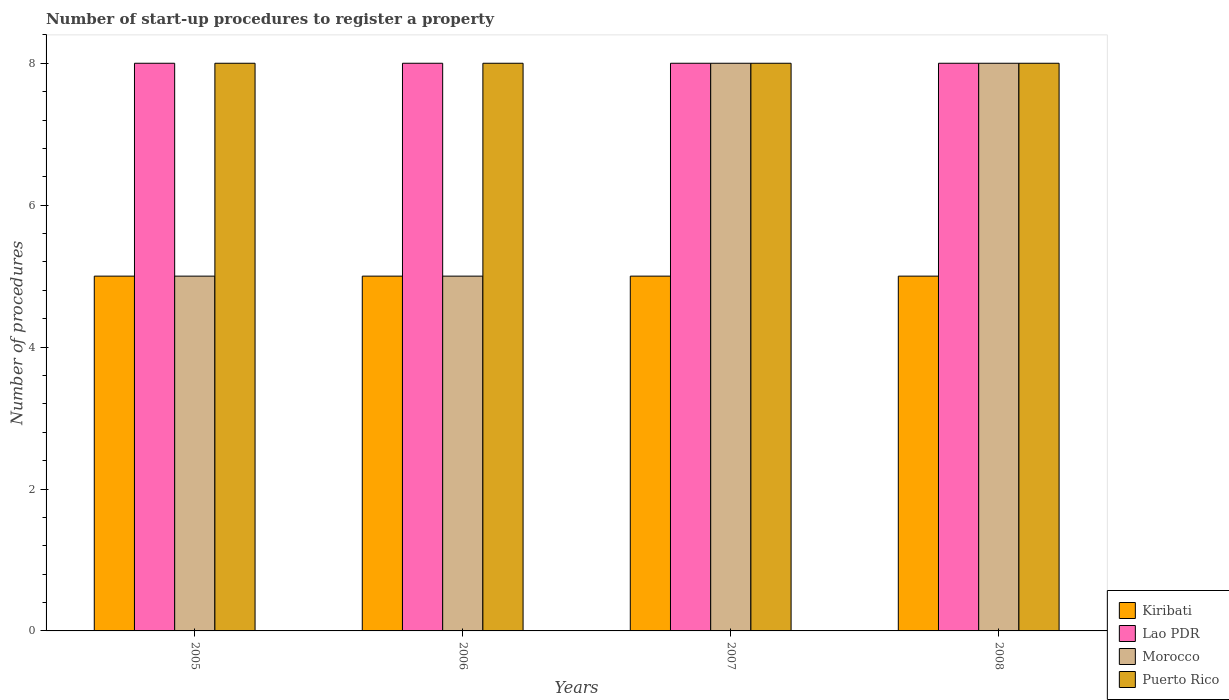Are the number of bars on each tick of the X-axis equal?
Provide a short and direct response. Yes. How many bars are there on the 4th tick from the left?
Keep it short and to the point. 4. How many bars are there on the 2nd tick from the right?
Your answer should be compact. 4. In how many cases, is the number of bars for a given year not equal to the number of legend labels?
Offer a terse response. 0. What is the number of procedures required to register a property in Puerto Rico in 2005?
Ensure brevity in your answer.  8. Across all years, what is the maximum number of procedures required to register a property in Lao PDR?
Ensure brevity in your answer.  8. Across all years, what is the minimum number of procedures required to register a property in Puerto Rico?
Keep it short and to the point. 8. In which year was the number of procedures required to register a property in Lao PDR minimum?
Give a very brief answer. 2005. What is the total number of procedures required to register a property in Kiribati in the graph?
Make the answer very short. 20. What is the difference between the number of procedures required to register a property in Puerto Rico in 2008 and the number of procedures required to register a property in Morocco in 2005?
Provide a succinct answer. 3. What is the average number of procedures required to register a property in Puerto Rico per year?
Ensure brevity in your answer.  8. In the year 2005, what is the difference between the number of procedures required to register a property in Lao PDR and number of procedures required to register a property in Puerto Rico?
Your response must be concise. 0. In how many years, is the number of procedures required to register a property in Puerto Rico greater than 1.6?
Your response must be concise. 4. What is the ratio of the number of procedures required to register a property in Morocco in 2007 to that in 2008?
Ensure brevity in your answer.  1. Is the difference between the number of procedures required to register a property in Lao PDR in 2005 and 2007 greater than the difference between the number of procedures required to register a property in Puerto Rico in 2005 and 2007?
Your answer should be very brief. No. In how many years, is the number of procedures required to register a property in Morocco greater than the average number of procedures required to register a property in Morocco taken over all years?
Give a very brief answer. 2. Is it the case that in every year, the sum of the number of procedures required to register a property in Morocco and number of procedures required to register a property in Kiribati is greater than the sum of number of procedures required to register a property in Puerto Rico and number of procedures required to register a property in Lao PDR?
Provide a short and direct response. No. What does the 4th bar from the left in 2007 represents?
Offer a very short reply. Puerto Rico. What does the 1st bar from the right in 2006 represents?
Offer a very short reply. Puerto Rico. Is it the case that in every year, the sum of the number of procedures required to register a property in Kiribati and number of procedures required to register a property in Puerto Rico is greater than the number of procedures required to register a property in Morocco?
Provide a succinct answer. Yes. Are all the bars in the graph horizontal?
Provide a succinct answer. No. How many years are there in the graph?
Your response must be concise. 4. Does the graph contain grids?
Offer a terse response. No. What is the title of the graph?
Your answer should be compact. Number of start-up procedures to register a property. Does "Israel" appear as one of the legend labels in the graph?
Ensure brevity in your answer.  No. What is the label or title of the Y-axis?
Provide a succinct answer. Number of procedures. What is the Number of procedures of Lao PDR in 2005?
Your answer should be very brief. 8. What is the Number of procedures of Morocco in 2005?
Your answer should be compact. 5. What is the Number of procedures of Puerto Rico in 2005?
Make the answer very short. 8. What is the Number of procedures of Kiribati in 2006?
Ensure brevity in your answer.  5. What is the Number of procedures of Lao PDR in 2006?
Your answer should be compact. 8. What is the Number of procedures of Morocco in 2006?
Make the answer very short. 5. What is the Number of procedures of Puerto Rico in 2006?
Offer a terse response. 8. What is the Number of procedures of Lao PDR in 2007?
Make the answer very short. 8. What is the Number of procedures in Morocco in 2007?
Offer a very short reply. 8. What is the Number of procedures of Lao PDR in 2008?
Provide a succinct answer. 8. What is the Number of procedures of Morocco in 2008?
Your answer should be very brief. 8. Across all years, what is the maximum Number of procedures of Lao PDR?
Ensure brevity in your answer.  8. Across all years, what is the maximum Number of procedures in Morocco?
Offer a terse response. 8. Across all years, what is the minimum Number of procedures of Kiribati?
Your answer should be very brief. 5. Across all years, what is the minimum Number of procedures in Lao PDR?
Ensure brevity in your answer.  8. Across all years, what is the minimum Number of procedures of Morocco?
Ensure brevity in your answer.  5. Across all years, what is the minimum Number of procedures in Puerto Rico?
Provide a succinct answer. 8. What is the total Number of procedures in Morocco in the graph?
Make the answer very short. 26. What is the difference between the Number of procedures in Kiribati in 2005 and that in 2006?
Provide a short and direct response. 0. What is the difference between the Number of procedures of Lao PDR in 2005 and that in 2006?
Provide a short and direct response. 0. What is the difference between the Number of procedures of Kiribati in 2005 and that in 2007?
Give a very brief answer. 0. What is the difference between the Number of procedures in Morocco in 2005 and that in 2007?
Your answer should be very brief. -3. What is the difference between the Number of procedures of Kiribati in 2005 and that in 2008?
Offer a very short reply. 0. What is the difference between the Number of procedures of Lao PDR in 2005 and that in 2008?
Provide a short and direct response. 0. What is the difference between the Number of procedures in Morocco in 2005 and that in 2008?
Ensure brevity in your answer.  -3. What is the difference between the Number of procedures in Puerto Rico in 2005 and that in 2008?
Provide a succinct answer. 0. What is the difference between the Number of procedures of Kiribati in 2006 and that in 2007?
Your response must be concise. 0. What is the difference between the Number of procedures in Lao PDR in 2006 and that in 2007?
Give a very brief answer. 0. What is the difference between the Number of procedures in Morocco in 2006 and that in 2007?
Make the answer very short. -3. What is the difference between the Number of procedures of Puerto Rico in 2006 and that in 2008?
Give a very brief answer. 0. What is the difference between the Number of procedures of Kiribati in 2007 and that in 2008?
Ensure brevity in your answer.  0. What is the difference between the Number of procedures in Lao PDR in 2007 and that in 2008?
Give a very brief answer. 0. What is the difference between the Number of procedures of Kiribati in 2005 and the Number of procedures of Lao PDR in 2006?
Your answer should be compact. -3. What is the difference between the Number of procedures of Kiribati in 2005 and the Number of procedures of Puerto Rico in 2006?
Offer a very short reply. -3. What is the difference between the Number of procedures of Lao PDR in 2005 and the Number of procedures of Puerto Rico in 2006?
Your answer should be very brief. 0. What is the difference between the Number of procedures in Kiribati in 2005 and the Number of procedures in Morocco in 2007?
Offer a very short reply. -3. What is the difference between the Number of procedures of Kiribati in 2005 and the Number of procedures of Puerto Rico in 2007?
Your answer should be compact. -3. What is the difference between the Number of procedures of Lao PDR in 2005 and the Number of procedures of Puerto Rico in 2007?
Give a very brief answer. 0. What is the difference between the Number of procedures of Lao PDR in 2005 and the Number of procedures of Puerto Rico in 2008?
Offer a very short reply. 0. What is the difference between the Number of procedures of Lao PDR in 2006 and the Number of procedures of Morocco in 2007?
Give a very brief answer. 0. What is the difference between the Number of procedures of Lao PDR in 2006 and the Number of procedures of Puerto Rico in 2007?
Provide a short and direct response. 0. What is the difference between the Number of procedures in Kiribati in 2006 and the Number of procedures in Lao PDR in 2008?
Your answer should be very brief. -3. What is the difference between the Number of procedures of Kiribati in 2006 and the Number of procedures of Morocco in 2008?
Offer a very short reply. -3. What is the difference between the Number of procedures in Kiribati in 2006 and the Number of procedures in Puerto Rico in 2008?
Your response must be concise. -3. What is the difference between the Number of procedures of Lao PDR in 2006 and the Number of procedures of Morocco in 2008?
Ensure brevity in your answer.  0. What is the difference between the Number of procedures in Morocco in 2006 and the Number of procedures in Puerto Rico in 2008?
Make the answer very short. -3. What is the difference between the Number of procedures in Kiribati in 2007 and the Number of procedures in Lao PDR in 2008?
Your response must be concise. -3. What is the difference between the Number of procedures in Kiribati in 2007 and the Number of procedures in Morocco in 2008?
Your answer should be compact. -3. What is the difference between the Number of procedures in Lao PDR in 2007 and the Number of procedures in Puerto Rico in 2008?
Keep it short and to the point. 0. What is the average Number of procedures in Kiribati per year?
Provide a short and direct response. 5. What is the average Number of procedures in Puerto Rico per year?
Ensure brevity in your answer.  8. In the year 2005, what is the difference between the Number of procedures in Kiribati and Number of procedures in Morocco?
Provide a succinct answer. 0. In the year 2005, what is the difference between the Number of procedures of Lao PDR and Number of procedures of Morocco?
Make the answer very short. 3. In the year 2005, what is the difference between the Number of procedures of Lao PDR and Number of procedures of Puerto Rico?
Provide a short and direct response. 0. In the year 2006, what is the difference between the Number of procedures in Kiribati and Number of procedures in Lao PDR?
Offer a very short reply. -3. In the year 2006, what is the difference between the Number of procedures of Kiribati and Number of procedures of Puerto Rico?
Make the answer very short. -3. In the year 2006, what is the difference between the Number of procedures of Lao PDR and Number of procedures of Puerto Rico?
Your response must be concise. 0. In the year 2007, what is the difference between the Number of procedures in Kiribati and Number of procedures in Lao PDR?
Provide a succinct answer. -3. In the year 2007, what is the difference between the Number of procedures in Kiribati and Number of procedures in Morocco?
Provide a short and direct response. -3. In the year 2008, what is the difference between the Number of procedures of Kiribati and Number of procedures of Puerto Rico?
Offer a terse response. -3. In the year 2008, what is the difference between the Number of procedures in Lao PDR and Number of procedures in Puerto Rico?
Keep it short and to the point. 0. What is the ratio of the Number of procedures in Lao PDR in 2005 to that in 2006?
Offer a very short reply. 1. What is the ratio of the Number of procedures in Puerto Rico in 2005 to that in 2006?
Ensure brevity in your answer.  1. What is the ratio of the Number of procedures in Lao PDR in 2005 to that in 2007?
Provide a succinct answer. 1. What is the ratio of the Number of procedures of Morocco in 2005 to that in 2007?
Offer a very short reply. 0.62. What is the ratio of the Number of procedures of Kiribati in 2005 to that in 2008?
Offer a very short reply. 1. What is the ratio of the Number of procedures in Morocco in 2005 to that in 2008?
Offer a terse response. 0.62. What is the ratio of the Number of procedures of Puerto Rico in 2005 to that in 2008?
Offer a very short reply. 1. What is the ratio of the Number of procedures in Kiribati in 2006 to that in 2007?
Offer a very short reply. 1. What is the ratio of the Number of procedures of Kiribati in 2006 to that in 2008?
Provide a succinct answer. 1. What is the ratio of the Number of procedures of Puerto Rico in 2006 to that in 2008?
Your response must be concise. 1. What is the ratio of the Number of procedures in Morocco in 2007 to that in 2008?
Your response must be concise. 1. What is the ratio of the Number of procedures in Puerto Rico in 2007 to that in 2008?
Offer a very short reply. 1. What is the difference between the highest and the second highest Number of procedures in Lao PDR?
Your response must be concise. 0. What is the difference between the highest and the lowest Number of procedures of Kiribati?
Your response must be concise. 0. What is the difference between the highest and the lowest Number of procedures in Lao PDR?
Give a very brief answer. 0. What is the difference between the highest and the lowest Number of procedures in Morocco?
Make the answer very short. 3. 